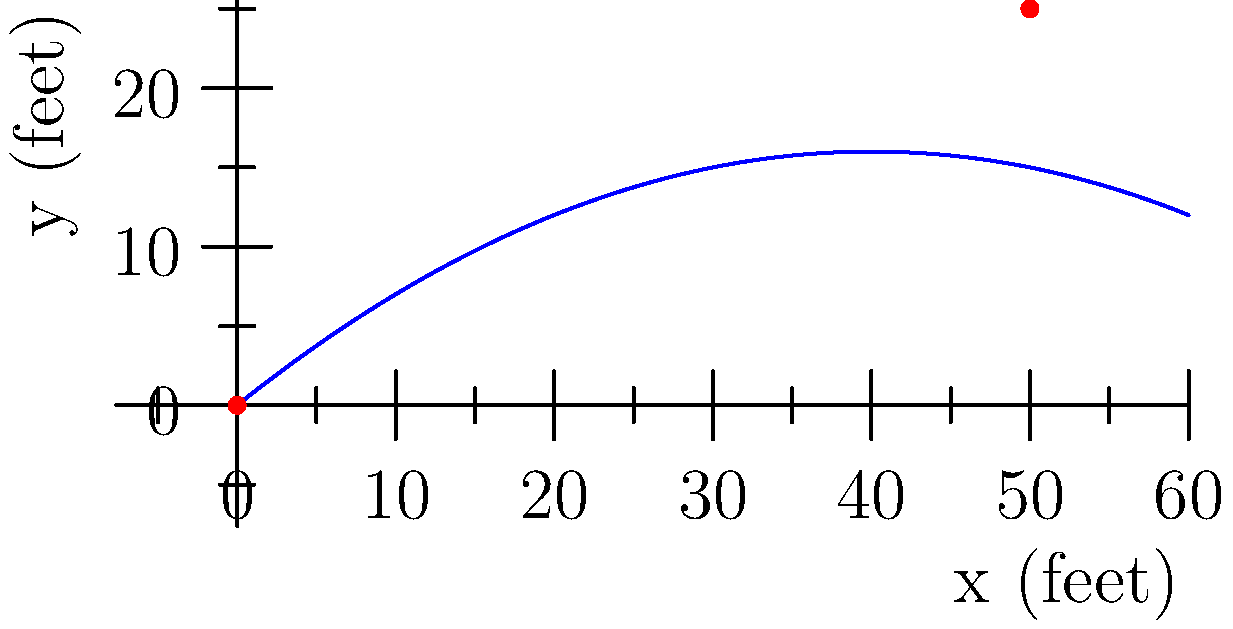As a retired firefighter, you're demonstrating water trajectory to rookie firefighters. The path of the water stream from your fire hose can be modeled by the equation $y = -0.01x^2 + 0.8x$, where $x$ and $y$ are measured in feet. What is the maximum height reached by the water stream, and at what horizontal distance from the nozzle does this occur? To find the maximum height of the water stream, we need to follow these steps:

1) The equation of the water stream's path is $y = -0.01x^2 + 0.8x$.

2) To find the maximum point, we need to find where the derivative of this function equals zero:
   $\frac{dy}{dx} = -0.02x + 0.8$

3) Set this equal to zero and solve for x:
   $-0.02x + 0.8 = 0$
   $-0.02x = -0.8$
   $x = 40$ feet

4) This x-value represents the horizontal distance where the maximum height occurs.

5) To find the maximum height, plug this x-value back into the original equation:
   $y = -0.01(40)^2 + 0.8(40)$
   $y = -16 + 32 = 16$ feet

Therefore, the maximum height of 16 feet is reached at a horizontal distance of 40 feet from the nozzle.
Answer: Maximum height: 16 feet; Horizontal distance: 40 feet 